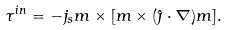<formula> <loc_0><loc_0><loc_500><loc_500>\tau ^ { i n } = - j _ { s } m \times [ m \times ( \hat { \jmath } \cdot \nabla ) m ] .</formula> 